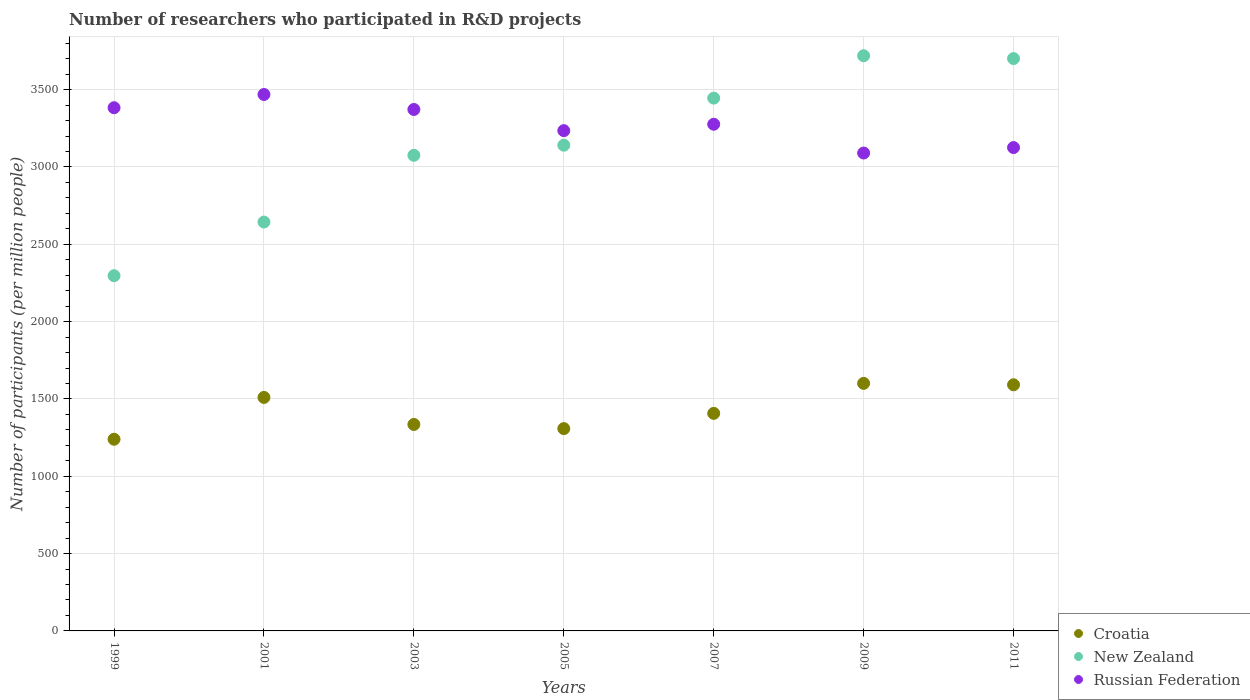How many different coloured dotlines are there?
Your answer should be very brief. 3. What is the number of researchers who participated in R&D projects in New Zealand in 2001?
Keep it short and to the point. 2643.65. Across all years, what is the maximum number of researchers who participated in R&D projects in Russian Federation?
Provide a succinct answer. 3468.55. Across all years, what is the minimum number of researchers who participated in R&D projects in New Zealand?
Your answer should be compact. 2296.8. In which year was the number of researchers who participated in R&D projects in New Zealand maximum?
Your response must be concise. 2009. In which year was the number of researchers who participated in R&D projects in Croatia minimum?
Your answer should be very brief. 1999. What is the total number of researchers who participated in R&D projects in New Zealand in the graph?
Make the answer very short. 2.20e+04. What is the difference between the number of researchers who participated in R&D projects in Croatia in 1999 and that in 2003?
Keep it short and to the point. -95.62. What is the difference between the number of researchers who participated in R&D projects in Russian Federation in 1999 and the number of researchers who participated in R&D projects in Croatia in 2007?
Offer a terse response. 1976.24. What is the average number of researchers who participated in R&D projects in Croatia per year?
Provide a short and direct response. 1427.3. In the year 2005, what is the difference between the number of researchers who participated in R&D projects in New Zealand and number of researchers who participated in R&D projects in Russian Federation?
Keep it short and to the point. -93.97. What is the ratio of the number of researchers who participated in R&D projects in New Zealand in 2009 to that in 2011?
Offer a very short reply. 1. Is the number of researchers who participated in R&D projects in New Zealand in 2001 less than that in 2003?
Your response must be concise. Yes. Is the difference between the number of researchers who participated in R&D projects in New Zealand in 2001 and 2009 greater than the difference between the number of researchers who participated in R&D projects in Russian Federation in 2001 and 2009?
Give a very brief answer. No. What is the difference between the highest and the second highest number of researchers who participated in R&D projects in New Zealand?
Give a very brief answer. 18.22. What is the difference between the highest and the lowest number of researchers who participated in R&D projects in Russian Federation?
Ensure brevity in your answer.  378.54. Is it the case that in every year, the sum of the number of researchers who participated in R&D projects in Croatia and number of researchers who participated in R&D projects in Russian Federation  is greater than the number of researchers who participated in R&D projects in New Zealand?
Your answer should be compact. Yes. Is the number of researchers who participated in R&D projects in New Zealand strictly greater than the number of researchers who participated in R&D projects in Russian Federation over the years?
Offer a terse response. No. Does the graph contain any zero values?
Your response must be concise. No. How many legend labels are there?
Give a very brief answer. 3. What is the title of the graph?
Give a very brief answer. Number of researchers who participated in R&D projects. What is the label or title of the X-axis?
Your answer should be compact. Years. What is the label or title of the Y-axis?
Your response must be concise. Number of participants (per million people). What is the Number of participants (per million people) in Croatia in 1999?
Offer a terse response. 1239.37. What is the Number of participants (per million people) in New Zealand in 1999?
Your response must be concise. 2296.8. What is the Number of participants (per million people) of Russian Federation in 1999?
Your answer should be compact. 3382.9. What is the Number of participants (per million people) in Croatia in 2001?
Make the answer very short. 1509.82. What is the Number of participants (per million people) of New Zealand in 2001?
Provide a short and direct response. 2643.65. What is the Number of participants (per million people) in Russian Federation in 2001?
Offer a terse response. 3468.55. What is the Number of participants (per million people) in Croatia in 2003?
Your response must be concise. 1334.99. What is the Number of participants (per million people) in New Zealand in 2003?
Make the answer very short. 3075.22. What is the Number of participants (per million people) of Russian Federation in 2003?
Offer a very short reply. 3371.6. What is the Number of participants (per million people) of Croatia in 2005?
Keep it short and to the point. 1308.11. What is the Number of participants (per million people) of New Zealand in 2005?
Give a very brief answer. 3140.74. What is the Number of participants (per million people) in Russian Federation in 2005?
Your response must be concise. 3234.71. What is the Number of participants (per million people) in Croatia in 2007?
Your answer should be very brief. 1406.67. What is the Number of participants (per million people) of New Zealand in 2007?
Offer a terse response. 3445. What is the Number of participants (per million people) in Russian Federation in 2007?
Offer a very short reply. 3276.12. What is the Number of participants (per million people) in Croatia in 2009?
Ensure brevity in your answer.  1600.55. What is the Number of participants (per million people) in New Zealand in 2009?
Offer a very short reply. 3719. What is the Number of participants (per million people) of Russian Federation in 2009?
Provide a short and direct response. 3090.01. What is the Number of participants (per million people) in Croatia in 2011?
Provide a short and direct response. 1591.56. What is the Number of participants (per million people) in New Zealand in 2011?
Provide a short and direct response. 3700.77. What is the Number of participants (per million people) of Russian Federation in 2011?
Make the answer very short. 3125.3. Across all years, what is the maximum Number of participants (per million people) of Croatia?
Offer a very short reply. 1600.55. Across all years, what is the maximum Number of participants (per million people) of New Zealand?
Provide a short and direct response. 3719. Across all years, what is the maximum Number of participants (per million people) in Russian Federation?
Your response must be concise. 3468.55. Across all years, what is the minimum Number of participants (per million people) in Croatia?
Give a very brief answer. 1239.37. Across all years, what is the minimum Number of participants (per million people) in New Zealand?
Give a very brief answer. 2296.8. Across all years, what is the minimum Number of participants (per million people) in Russian Federation?
Your response must be concise. 3090.01. What is the total Number of participants (per million people) of Croatia in the graph?
Your answer should be very brief. 9991.07. What is the total Number of participants (per million people) of New Zealand in the graph?
Offer a very short reply. 2.20e+04. What is the total Number of participants (per million people) of Russian Federation in the graph?
Make the answer very short. 2.29e+04. What is the difference between the Number of participants (per million people) in Croatia in 1999 and that in 2001?
Keep it short and to the point. -270.46. What is the difference between the Number of participants (per million people) of New Zealand in 1999 and that in 2001?
Your answer should be very brief. -346.85. What is the difference between the Number of participants (per million people) in Russian Federation in 1999 and that in 2001?
Offer a very short reply. -85.65. What is the difference between the Number of participants (per million people) of Croatia in 1999 and that in 2003?
Your answer should be very brief. -95.62. What is the difference between the Number of participants (per million people) in New Zealand in 1999 and that in 2003?
Your answer should be compact. -778.43. What is the difference between the Number of participants (per million people) in Russian Federation in 1999 and that in 2003?
Provide a short and direct response. 11.3. What is the difference between the Number of participants (per million people) in Croatia in 1999 and that in 2005?
Offer a terse response. -68.75. What is the difference between the Number of participants (per million people) in New Zealand in 1999 and that in 2005?
Your answer should be very brief. -843.94. What is the difference between the Number of participants (per million people) of Russian Federation in 1999 and that in 2005?
Your answer should be very brief. 148.19. What is the difference between the Number of participants (per million people) of Croatia in 1999 and that in 2007?
Offer a terse response. -167.3. What is the difference between the Number of participants (per million people) in New Zealand in 1999 and that in 2007?
Ensure brevity in your answer.  -1148.21. What is the difference between the Number of participants (per million people) of Russian Federation in 1999 and that in 2007?
Provide a short and direct response. 106.78. What is the difference between the Number of participants (per million people) in Croatia in 1999 and that in 2009?
Provide a succinct answer. -361.18. What is the difference between the Number of participants (per million people) of New Zealand in 1999 and that in 2009?
Your answer should be compact. -1422.2. What is the difference between the Number of participants (per million people) of Russian Federation in 1999 and that in 2009?
Ensure brevity in your answer.  292.89. What is the difference between the Number of participants (per million people) of Croatia in 1999 and that in 2011?
Offer a very short reply. -352.19. What is the difference between the Number of participants (per million people) in New Zealand in 1999 and that in 2011?
Provide a short and direct response. -1403.98. What is the difference between the Number of participants (per million people) of Russian Federation in 1999 and that in 2011?
Your response must be concise. 257.6. What is the difference between the Number of participants (per million people) in Croatia in 2001 and that in 2003?
Offer a terse response. 174.83. What is the difference between the Number of participants (per million people) in New Zealand in 2001 and that in 2003?
Your answer should be compact. -431.58. What is the difference between the Number of participants (per million people) of Russian Federation in 2001 and that in 2003?
Provide a short and direct response. 96.95. What is the difference between the Number of participants (per million people) of Croatia in 2001 and that in 2005?
Give a very brief answer. 201.71. What is the difference between the Number of participants (per million people) of New Zealand in 2001 and that in 2005?
Ensure brevity in your answer.  -497.09. What is the difference between the Number of participants (per million people) of Russian Federation in 2001 and that in 2005?
Offer a very short reply. 233.85. What is the difference between the Number of participants (per million people) in Croatia in 2001 and that in 2007?
Offer a very short reply. 103.16. What is the difference between the Number of participants (per million people) of New Zealand in 2001 and that in 2007?
Make the answer very short. -801.36. What is the difference between the Number of participants (per million people) in Russian Federation in 2001 and that in 2007?
Provide a short and direct response. 192.43. What is the difference between the Number of participants (per million people) of Croatia in 2001 and that in 2009?
Your answer should be very brief. -90.72. What is the difference between the Number of participants (per million people) of New Zealand in 2001 and that in 2009?
Your answer should be very brief. -1075.35. What is the difference between the Number of participants (per million people) of Russian Federation in 2001 and that in 2009?
Provide a succinct answer. 378.54. What is the difference between the Number of participants (per million people) in Croatia in 2001 and that in 2011?
Keep it short and to the point. -81.73. What is the difference between the Number of participants (per million people) of New Zealand in 2001 and that in 2011?
Provide a short and direct response. -1057.13. What is the difference between the Number of participants (per million people) of Russian Federation in 2001 and that in 2011?
Your answer should be compact. 343.25. What is the difference between the Number of participants (per million people) in Croatia in 2003 and that in 2005?
Your response must be concise. 26.88. What is the difference between the Number of participants (per million people) of New Zealand in 2003 and that in 2005?
Ensure brevity in your answer.  -65.51. What is the difference between the Number of participants (per million people) in Russian Federation in 2003 and that in 2005?
Offer a very short reply. 136.9. What is the difference between the Number of participants (per million people) in Croatia in 2003 and that in 2007?
Your answer should be compact. -71.67. What is the difference between the Number of participants (per million people) of New Zealand in 2003 and that in 2007?
Your answer should be compact. -369.78. What is the difference between the Number of participants (per million people) in Russian Federation in 2003 and that in 2007?
Your answer should be very brief. 95.48. What is the difference between the Number of participants (per million people) of Croatia in 2003 and that in 2009?
Your answer should be very brief. -265.55. What is the difference between the Number of participants (per million people) of New Zealand in 2003 and that in 2009?
Keep it short and to the point. -643.77. What is the difference between the Number of participants (per million people) of Russian Federation in 2003 and that in 2009?
Ensure brevity in your answer.  281.59. What is the difference between the Number of participants (per million people) of Croatia in 2003 and that in 2011?
Make the answer very short. -256.57. What is the difference between the Number of participants (per million people) of New Zealand in 2003 and that in 2011?
Your answer should be compact. -625.55. What is the difference between the Number of participants (per million people) of Russian Federation in 2003 and that in 2011?
Your answer should be compact. 246.3. What is the difference between the Number of participants (per million people) of Croatia in 2005 and that in 2007?
Provide a short and direct response. -98.55. What is the difference between the Number of participants (per million people) of New Zealand in 2005 and that in 2007?
Your answer should be compact. -304.27. What is the difference between the Number of participants (per million people) of Russian Federation in 2005 and that in 2007?
Offer a very short reply. -41.41. What is the difference between the Number of participants (per million people) of Croatia in 2005 and that in 2009?
Give a very brief answer. -292.43. What is the difference between the Number of participants (per million people) of New Zealand in 2005 and that in 2009?
Your response must be concise. -578.26. What is the difference between the Number of participants (per million people) in Russian Federation in 2005 and that in 2009?
Provide a short and direct response. 144.7. What is the difference between the Number of participants (per million people) of Croatia in 2005 and that in 2011?
Your answer should be very brief. -283.44. What is the difference between the Number of participants (per million people) of New Zealand in 2005 and that in 2011?
Your answer should be very brief. -560.04. What is the difference between the Number of participants (per million people) of Russian Federation in 2005 and that in 2011?
Offer a terse response. 109.41. What is the difference between the Number of participants (per million people) in Croatia in 2007 and that in 2009?
Offer a very short reply. -193.88. What is the difference between the Number of participants (per million people) in New Zealand in 2007 and that in 2009?
Give a very brief answer. -273.99. What is the difference between the Number of participants (per million people) in Russian Federation in 2007 and that in 2009?
Ensure brevity in your answer.  186.11. What is the difference between the Number of participants (per million people) in Croatia in 2007 and that in 2011?
Provide a short and direct response. -184.89. What is the difference between the Number of participants (per million people) of New Zealand in 2007 and that in 2011?
Your response must be concise. -255.77. What is the difference between the Number of participants (per million people) of Russian Federation in 2007 and that in 2011?
Provide a short and direct response. 150.82. What is the difference between the Number of participants (per million people) in Croatia in 2009 and that in 2011?
Provide a short and direct response. 8.99. What is the difference between the Number of participants (per million people) of New Zealand in 2009 and that in 2011?
Keep it short and to the point. 18.22. What is the difference between the Number of participants (per million people) of Russian Federation in 2009 and that in 2011?
Your answer should be compact. -35.29. What is the difference between the Number of participants (per million people) in Croatia in 1999 and the Number of participants (per million people) in New Zealand in 2001?
Keep it short and to the point. -1404.28. What is the difference between the Number of participants (per million people) in Croatia in 1999 and the Number of participants (per million people) in Russian Federation in 2001?
Keep it short and to the point. -2229.18. What is the difference between the Number of participants (per million people) in New Zealand in 1999 and the Number of participants (per million people) in Russian Federation in 2001?
Your response must be concise. -1171.76. What is the difference between the Number of participants (per million people) of Croatia in 1999 and the Number of participants (per million people) of New Zealand in 2003?
Make the answer very short. -1835.85. What is the difference between the Number of participants (per million people) in Croatia in 1999 and the Number of participants (per million people) in Russian Federation in 2003?
Make the answer very short. -2132.23. What is the difference between the Number of participants (per million people) in New Zealand in 1999 and the Number of participants (per million people) in Russian Federation in 2003?
Keep it short and to the point. -1074.81. What is the difference between the Number of participants (per million people) of Croatia in 1999 and the Number of participants (per million people) of New Zealand in 2005?
Make the answer very short. -1901.37. What is the difference between the Number of participants (per million people) in Croatia in 1999 and the Number of participants (per million people) in Russian Federation in 2005?
Your answer should be compact. -1995.34. What is the difference between the Number of participants (per million people) in New Zealand in 1999 and the Number of participants (per million people) in Russian Federation in 2005?
Your answer should be compact. -937.91. What is the difference between the Number of participants (per million people) of Croatia in 1999 and the Number of participants (per million people) of New Zealand in 2007?
Your answer should be compact. -2205.63. What is the difference between the Number of participants (per million people) in Croatia in 1999 and the Number of participants (per million people) in Russian Federation in 2007?
Provide a succinct answer. -2036.75. What is the difference between the Number of participants (per million people) of New Zealand in 1999 and the Number of participants (per million people) of Russian Federation in 2007?
Ensure brevity in your answer.  -979.32. What is the difference between the Number of participants (per million people) of Croatia in 1999 and the Number of participants (per million people) of New Zealand in 2009?
Give a very brief answer. -2479.63. What is the difference between the Number of participants (per million people) in Croatia in 1999 and the Number of participants (per million people) in Russian Federation in 2009?
Ensure brevity in your answer.  -1850.64. What is the difference between the Number of participants (per million people) of New Zealand in 1999 and the Number of participants (per million people) of Russian Federation in 2009?
Your answer should be compact. -793.21. What is the difference between the Number of participants (per million people) of Croatia in 1999 and the Number of participants (per million people) of New Zealand in 2011?
Ensure brevity in your answer.  -2461.41. What is the difference between the Number of participants (per million people) in Croatia in 1999 and the Number of participants (per million people) in Russian Federation in 2011?
Your answer should be compact. -1885.93. What is the difference between the Number of participants (per million people) in New Zealand in 1999 and the Number of participants (per million people) in Russian Federation in 2011?
Keep it short and to the point. -828.5. What is the difference between the Number of participants (per million people) in Croatia in 2001 and the Number of participants (per million people) in New Zealand in 2003?
Keep it short and to the point. -1565.4. What is the difference between the Number of participants (per million people) in Croatia in 2001 and the Number of participants (per million people) in Russian Federation in 2003?
Offer a very short reply. -1861.78. What is the difference between the Number of participants (per million people) in New Zealand in 2001 and the Number of participants (per million people) in Russian Federation in 2003?
Provide a succinct answer. -727.95. What is the difference between the Number of participants (per million people) in Croatia in 2001 and the Number of participants (per million people) in New Zealand in 2005?
Provide a succinct answer. -1630.91. What is the difference between the Number of participants (per million people) of Croatia in 2001 and the Number of participants (per million people) of Russian Federation in 2005?
Offer a terse response. -1724.88. What is the difference between the Number of participants (per million people) in New Zealand in 2001 and the Number of participants (per million people) in Russian Federation in 2005?
Your response must be concise. -591.06. What is the difference between the Number of participants (per million people) in Croatia in 2001 and the Number of participants (per million people) in New Zealand in 2007?
Offer a very short reply. -1935.18. What is the difference between the Number of participants (per million people) in Croatia in 2001 and the Number of participants (per million people) in Russian Federation in 2007?
Give a very brief answer. -1766.3. What is the difference between the Number of participants (per million people) in New Zealand in 2001 and the Number of participants (per million people) in Russian Federation in 2007?
Make the answer very short. -632.47. What is the difference between the Number of participants (per million people) of Croatia in 2001 and the Number of participants (per million people) of New Zealand in 2009?
Offer a terse response. -2209.17. What is the difference between the Number of participants (per million people) in Croatia in 2001 and the Number of participants (per million people) in Russian Federation in 2009?
Your answer should be very brief. -1580.19. What is the difference between the Number of participants (per million people) of New Zealand in 2001 and the Number of participants (per million people) of Russian Federation in 2009?
Ensure brevity in your answer.  -446.36. What is the difference between the Number of participants (per million people) of Croatia in 2001 and the Number of participants (per million people) of New Zealand in 2011?
Your answer should be compact. -2190.95. What is the difference between the Number of participants (per million people) in Croatia in 2001 and the Number of participants (per million people) in Russian Federation in 2011?
Provide a short and direct response. -1615.48. What is the difference between the Number of participants (per million people) in New Zealand in 2001 and the Number of participants (per million people) in Russian Federation in 2011?
Your answer should be compact. -481.65. What is the difference between the Number of participants (per million people) in Croatia in 2003 and the Number of participants (per million people) in New Zealand in 2005?
Ensure brevity in your answer.  -1805.75. What is the difference between the Number of participants (per million people) of Croatia in 2003 and the Number of participants (per million people) of Russian Federation in 2005?
Your response must be concise. -1899.72. What is the difference between the Number of participants (per million people) of New Zealand in 2003 and the Number of participants (per million people) of Russian Federation in 2005?
Ensure brevity in your answer.  -159.48. What is the difference between the Number of participants (per million people) in Croatia in 2003 and the Number of participants (per million people) in New Zealand in 2007?
Give a very brief answer. -2110.01. What is the difference between the Number of participants (per million people) in Croatia in 2003 and the Number of participants (per million people) in Russian Federation in 2007?
Your answer should be very brief. -1941.13. What is the difference between the Number of participants (per million people) of New Zealand in 2003 and the Number of participants (per million people) of Russian Federation in 2007?
Give a very brief answer. -200.9. What is the difference between the Number of participants (per million people) of Croatia in 2003 and the Number of participants (per million people) of New Zealand in 2009?
Provide a succinct answer. -2384.01. What is the difference between the Number of participants (per million people) in Croatia in 2003 and the Number of participants (per million people) in Russian Federation in 2009?
Your answer should be very brief. -1755.02. What is the difference between the Number of participants (per million people) in New Zealand in 2003 and the Number of participants (per million people) in Russian Federation in 2009?
Offer a terse response. -14.79. What is the difference between the Number of participants (per million people) in Croatia in 2003 and the Number of participants (per million people) in New Zealand in 2011?
Your answer should be compact. -2365.78. What is the difference between the Number of participants (per million people) of Croatia in 2003 and the Number of participants (per million people) of Russian Federation in 2011?
Your response must be concise. -1790.31. What is the difference between the Number of participants (per million people) of New Zealand in 2003 and the Number of participants (per million people) of Russian Federation in 2011?
Give a very brief answer. -50.08. What is the difference between the Number of participants (per million people) of Croatia in 2005 and the Number of participants (per million people) of New Zealand in 2007?
Offer a very short reply. -2136.89. What is the difference between the Number of participants (per million people) in Croatia in 2005 and the Number of participants (per million people) in Russian Federation in 2007?
Keep it short and to the point. -1968.01. What is the difference between the Number of participants (per million people) of New Zealand in 2005 and the Number of participants (per million people) of Russian Federation in 2007?
Your answer should be compact. -135.39. What is the difference between the Number of participants (per million people) in Croatia in 2005 and the Number of participants (per million people) in New Zealand in 2009?
Make the answer very short. -2410.88. What is the difference between the Number of participants (per million people) in Croatia in 2005 and the Number of participants (per million people) in Russian Federation in 2009?
Your answer should be very brief. -1781.9. What is the difference between the Number of participants (per million people) in New Zealand in 2005 and the Number of participants (per million people) in Russian Federation in 2009?
Provide a short and direct response. 50.73. What is the difference between the Number of participants (per million people) in Croatia in 2005 and the Number of participants (per million people) in New Zealand in 2011?
Offer a terse response. -2392.66. What is the difference between the Number of participants (per million people) in Croatia in 2005 and the Number of participants (per million people) in Russian Federation in 2011?
Your answer should be compact. -1817.19. What is the difference between the Number of participants (per million people) in New Zealand in 2005 and the Number of participants (per million people) in Russian Federation in 2011?
Give a very brief answer. 15.44. What is the difference between the Number of participants (per million people) in Croatia in 2007 and the Number of participants (per million people) in New Zealand in 2009?
Keep it short and to the point. -2312.33. What is the difference between the Number of participants (per million people) in Croatia in 2007 and the Number of participants (per million people) in Russian Federation in 2009?
Provide a succinct answer. -1683.35. What is the difference between the Number of participants (per million people) in New Zealand in 2007 and the Number of participants (per million people) in Russian Federation in 2009?
Offer a terse response. 354.99. What is the difference between the Number of participants (per million people) in Croatia in 2007 and the Number of participants (per million people) in New Zealand in 2011?
Keep it short and to the point. -2294.11. What is the difference between the Number of participants (per million people) in Croatia in 2007 and the Number of participants (per million people) in Russian Federation in 2011?
Provide a succinct answer. -1718.64. What is the difference between the Number of participants (per million people) of New Zealand in 2007 and the Number of participants (per million people) of Russian Federation in 2011?
Your answer should be very brief. 319.7. What is the difference between the Number of participants (per million people) of Croatia in 2009 and the Number of participants (per million people) of New Zealand in 2011?
Your response must be concise. -2100.23. What is the difference between the Number of participants (per million people) in Croatia in 2009 and the Number of participants (per million people) in Russian Federation in 2011?
Ensure brevity in your answer.  -1524.76. What is the difference between the Number of participants (per million people) of New Zealand in 2009 and the Number of participants (per million people) of Russian Federation in 2011?
Your answer should be very brief. 593.7. What is the average Number of participants (per million people) in Croatia per year?
Keep it short and to the point. 1427.3. What is the average Number of participants (per million people) of New Zealand per year?
Your answer should be very brief. 3145.88. What is the average Number of participants (per million people) in Russian Federation per year?
Keep it short and to the point. 3278.46. In the year 1999, what is the difference between the Number of participants (per million people) in Croatia and Number of participants (per million people) in New Zealand?
Keep it short and to the point. -1057.43. In the year 1999, what is the difference between the Number of participants (per million people) of Croatia and Number of participants (per million people) of Russian Federation?
Keep it short and to the point. -2143.53. In the year 1999, what is the difference between the Number of participants (per million people) in New Zealand and Number of participants (per million people) in Russian Federation?
Offer a terse response. -1086.1. In the year 2001, what is the difference between the Number of participants (per million people) in Croatia and Number of participants (per million people) in New Zealand?
Provide a short and direct response. -1133.82. In the year 2001, what is the difference between the Number of participants (per million people) of Croatia and Number of participants (per million people) of Russian Federation?
Give a very brief answer. -1958.73. In the year 2001, what is the difference between the Number of participants (per million people) in New Zealand and Number of participants (per million people) in Russian Federation?
Your response must be concise. -824.91. In the year 2003, what is the difference between the Number of participants (per million people) of Croatia and Number of participants (per million people) of New Zealand?
Provide a short and direct response. -1740.23. In the year 2003, what is the difference between the Number of participants (per million people) in Croatia and Number of participants (per million people) in Russian Federation?
Give a very brief answer. -2036.61. In the year 2003, what is the difference between the Number of participants (per million people) of New Zealand and Number of participants (per million people) of Russian Federation?
Your response must be concise. -296.38. In the year 2005, what is the difference between the Number of participants (per million people) of Croatia and Number of participants (per million people) of New Zealand?
Offer a terse response. -1832.62. In the year 2005, what is the difference between the Number of participants (per million people) of Croatia and Number of participants (per million people) of Russian Federation?
Your response must be concise. -1926.59. In the year 2005, what is the difference between the Number of participants (per million people) in New Zealand and Number of participants (per million people) in Russian Federation?
Keep it short and to the point. -93.97. In the year 2007, what is the difference between the Number of participants (per million people) of Croatia and Number of participants (per million people) of New Zealand?
Ensure brevity in your answer.  -2038.34. In the year 2007, what is the difference between the Number of participants (per million people) in Croatia and Number of participants (per million people) in Russian Federation?
Your response must be concise. -1869.46. In the year 2007, what is the difference between the Number of participants (per million people) of New Zealand and Number of participants (per million people) of Russian Federation?
Offer a very short reply. 168.88. In the year 2009, what is the difference between the Number of participants (per million people) in Croatia and Number of participants (per million people) in New Zealand?
Provide a succinct answer. -2118.45. In the year 2009, what is the difference between the Number of participants (per million people) of Croatia and Number of participants (per million people) of Russian Federation?
Give a very brief answer. -1489.47. In the year 2009, what is the difference between the Number of participants (per million people) of New Zealand and Number of participants (per million people) of Russian Federation?
Provide a short and direct response. 628.99. In the year 2011, what is the difference between the Number of participants (per million people) of Croatia and Number of participants (per million people) of New Zealand?
Your response must be concise. -2109.22. In the year 2011, what is the difference between the Number of participants (per million people) in Croatia and Number of participants (per million people) in Russian Federation?
Offer a terse response. -1533.74. In the year 2011, what is the difference between the Number of participants (per million people) in New Zealand and Number of participants (per million people) in Russian Federation?
Keep it short and to the point. 575.47. What is the ratio of the Number of participants (per million people) in Croatia in 1999 to that in 2001?
Your answer should be compact. 0.82. What is the ratio of the Number of participants (per million people) in New Zealand in 1999 to that in 2001?
Your response must be concise. 0.87. What is the ratio of the Number of participants (per million people) in Russian Federation in 1999 to that in 2001?
Offer a very short reply. 0.98. What is the ratio of the Number of participants (per million people) of Croatia in 1999 to that in 2003?
Keep it short and to the point. 0.93. What is the ratio of the Number of participants (per million people) in New Zealand in 1999 to that in 2003?
Make the answer very short. 0.75. What is the ratio of the Number of participants (per million people) in Croatia in 1999 to that in 2005?
Make the answer very short. 0.95. What is the ratio of the Number of participants (per million people) in New Zealand in 1999 to that in 2005?
Your answer should be compact. 0.73. What is the ratio of the Number of participants (per million people) in Russian Federation in 1999 to that in 2005?
Keep it short and to the point. 1.05. What is the ratio of the Number of participants (per million people) of Croatia in 1999 to that in 2007?
Offer a very short reply. 0.88. What is the ratio of the Number of participants (per million people) of Russian Federation in 1999 to that in 2007?
Offer a terse response. 1.03. What is the ratio of the Number of participants (per million people) in Croatia in 1999 to that in 2009?
Provide a succinct answer. 0.77. What is the ratio of the Number of participants (per million people) of New Zealand in 1999 to that in 2009?
Keep it short and to the point. 0.62. What is the ratio of the Number of participants (per million people) in Russian Federation in 1999 to that in 2009?
Keep it short and to the point. 1.09. What is the ratio of the Number of participants (per million people) of Croatia in 1999 to that in 2011?
Make the answer very short. 0.78. What is the ratio of the Number of participants (per million people) in New Zealand in 1999 to that in 2011?
Give a very brief answer. 0.62. What is the ratio of the Number of participants (per million people) in Russian Federation in 1999 to that in 2011?
Provide a short and direct response. 1.08. What is the ratio of the Number of participants (per million people) in Croatia in 2001 to that in 2003?
Keep it short and to the point. 1.13. What is the ratio of the Number of participants (per million people) in New Zealand in 2001 to that in 2003?
Your response must be concise. 0.86. What is the ratio of the Number of participants (per million people) in Russian Federation in 2001 to that in 2003?
Offer a very short reply. 1.03. What is the ratio of the Number of participants (per million people) in Croatia in 2001 to that in 2005?
Provide a short and direct response. 1.15. What is the ratio of the Number of participants (per million people) of New Zealand in 2001 to that in 2005?
Your answer should be very brief. 0.84. What is the ratio of the Number of participants (per million people) of Russian Federation in 2001 to that in 2005?
Your answer should be compact. 1.07. What is the ratio of the Number of participants (per million people) in Croatia in 2001 to that in 2007?
Keep it short and to the point. 1.07. What is the ratio of the Number of participants (per million people) in New Zealand in 2001 to that in 2007?
Give a very brief answer. 0.77. What is the ratio of the Number of participants (per million people) in Russian Federation in 2001 to that in 2007?
Ensure brevity in your answer.  1.06. What is the ratio of the Number of participants (per million people) of Croatia in 2001 to that in 2009?
Your response must be concise. 0.94. What is the ratio of the Number of participants (per million people) in New Zealand in 2001 to that in 2009?
Ensure brevity in your answer.  0.71. What is the ratio of the Number of participants (per million people) in Russian Federation in 2001 to that in 2009?
Give a very brief answer. 1.12. What is the ratio of the Number of participants (per million people) in Croatia in 2001 to that in 2011?
Make the answer very short. 0.95. What is the ratio of the Number of participants (per million people) in New Zealand in 2001 to that in 2011?
Give a very brief answer. 0.71. What is the ratio of the Number of participants (per million people) in Russian Federation in 2001 to that in 2011?
Keep it short and to the point. 1.11. What is the ratio of the Number of participants (per million people) in Croatia in 2003 to that in 2005?
Give a very brief answer. 1.02. What is the ratio of the Number of participants (per million people) of New Zealand in 2003 to that in 2005?
Give a very brief answer. 0.98. What is the ratio of the Number of participants (per million people) of Russian Federation in 2003 to that in 2005?
Your response must be concise. 1.04. What is the ratio of the Number of participants (per million people) of Croatia in 2003 to that in 2007?
Give a very brief answer. 0.95. What is the ratio of the Number of participants (per million people) in New Zealand in 2003 to that in 2007?
Keep it short and to the point. 0.89. What is the ratio of the Number of participants (per million people) in Russian Federation in 2003 to that in 2007?
Ensure brevity in your answer.  1.03. What is the ratio of the Number of participants (per million people) of Croatia in 2003 to that in 2009?
Give a very brief answer. 0.83. What is the ratio of the Number of participants (per million people) in New Zealand in 2003 to that in 2009?
Offer a terse response. 0.83. What is the ratio of the Number of participants (per million people) of Russian Federation in 2003 to that in 2009?
Your answer should be compact. 1.09. What is the ratio of the Number of participants (per million people) in Croatia in 2003 to that in 2011?
Offer a terse response. 0.84. What is the ratio of the Number of participants (per million people) in New Zealand in 2003 to that in 2011?
Provide a short and direct response. 0.83. What is the ratio of the Number of participants (per million people) in Russian Federation in 2003 to that in 2011?
Your answer should be compact. 1.08. What is the ratio of the Number of participants (per million people) of Croatia in 2005 to that in 2007?
Provide a short and direct response. 0.93. What is the ratio of the Number of participants (per million people) of New Zealand in 2005 to that in 2007?
Offer a terse response. 0.91. What is the ratio of the Number of participants (per million people) of Russian Federation in 2005 to that in 2007?
Provide a succinct answer. 0.99. What is the ratio of the Number of participants (per million people) of Croatia in 2005 to that in 2009?
Keep it short and to the point. 0.82. What is the ratio of the Number of participants (per million people) in New Zealand in 2005 to that in 2009?
Your response must be concise. 0.84. What is the ratio of the Number of participants (per million people) of Russian Federation in 2005 to that in 2009?
Keep it short and to the point. 1.05. What is the ratio of the Number of participants (per million people) of Croatia in 2005 to that in 2011?
Provide a short and direct response. 0.82. What is the ratio of the Number of participants (per million people) of New Zealand in 2005 to that in 2011?
Offer a terse response. 0.85. What is the ratio of the Number of participants (per million people) of Russian Federation in 2005 to that in 2011?
Ensure brevity in your answer.  1.03. What is the ratio of the Number of participants (per million people) in Croatia in 2007 to that in 2009?
Offer a terse response. 0.88. What is the ratio of the Number of participants (per million people) of New Zealand in 2007 to that in 2009?
Your answer should be very brief. 0.93. What is the ratio of the Number of participants (per million people) in Russian Federation in 2007 to that in 2009?
Your answer should be very brief. 1.06. What is the ratio of the Number of participants (per million people) of Croatia in 2007 to that in 2011?
Give a very brief answer. 0.88. What is the ratio of the Number of participants (per million people) in New Zealand in 2007 to that in 2011?
Provide a succinct answer. 0.93. What is the ratio of the Number of participants (per million people) in Russian Federation in 2007 to that in 2011?
Your answer should be compact. 1.05. What is the ratio of the Number of participants (per million people) of Croatia in 2009 to that in 2011?
Give a very brief answer. 1.01. What is the ratio of the Number of participants (per million people) of New Zealand in 2009 to that in 2011?
Make the answer very short. 1. What is the ratio of the Number of participants (per million people) in Russian Federation in 2009 to that in 2011?
Provide a succinct answer. 0.99. What is the difference between the highest and the second highest Number of participants (per million people) of Croatia?
Your response must be concise. 8.99. What is the difference between the highest and the second highest Number of participants (per million people) in New Zealand?
Offer a terse response. 18.22. What is the difference between the highest and the second highest Number of participants (per million people) of Russian Federation?
Offer a terse response. 85.65. What is the difference between the highest and the lowest Number of participants (per million people) of Croatia?
Offer a terse response. 361.18. What is the difference between the highest and the lowest Number of participants (per million people) in New Zealand?
Offer a terse response. 1422.2. What is the difference between the highest and the lowest Number of participants (per million people) in Russian Federation?
Provide a succinct answer. 378.54. 